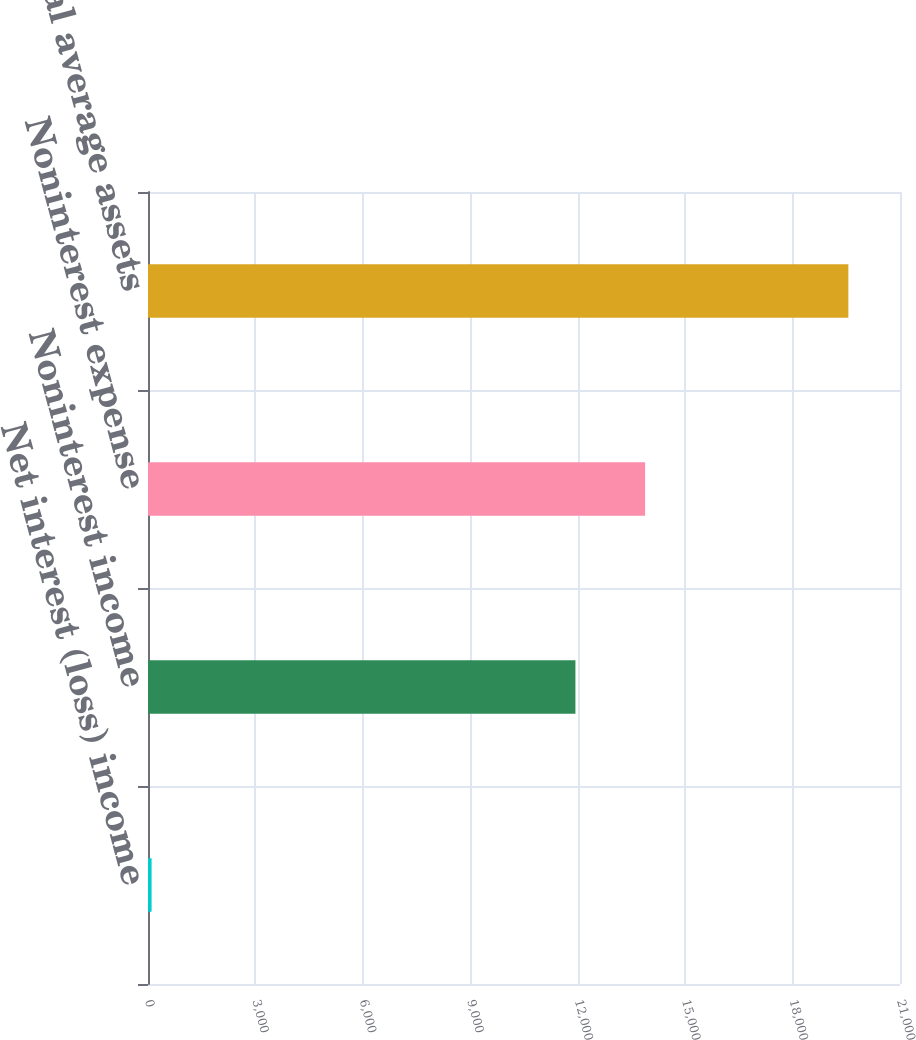<chart> <loc_0><loc_0><loc_500><loc_500><bar_chart><fcel>Net interest (loss) income<fcel>Noninterest income<fcel>Noninterest expense<fcel>Total average assets<nl><fcel>100<fcel>11936<fcel>13881.8<fcel>19558<nl></chart> 